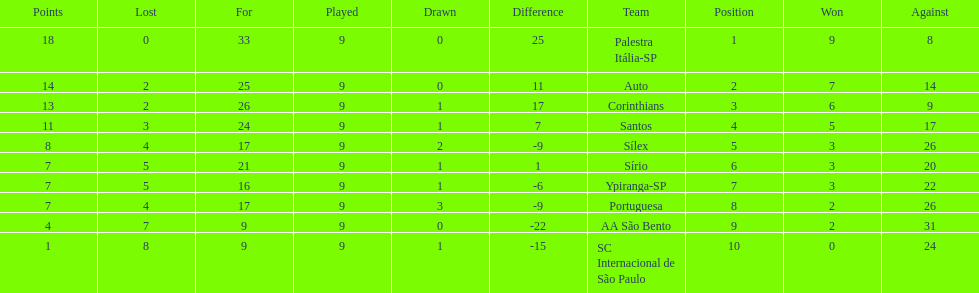Brazilian football in 1926 what teams had no draws? Palestra Itália-SP, Auto, AA São Bento. Of the teams with no draws name the 2 who lost the lease. Palestra Itália-SP, Auto. What team of the 2 who lost the least and had no draws had the highest difference? Palestra Itália-SP. 